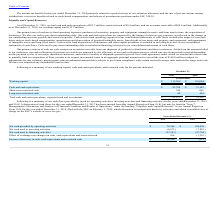According to Maxlinear's financial document, How much was the Net cash used in financing activities for the year ended December 31, 2018? Based on the financial document, the answer is $93.8 million. Also, can you calculate: What is the average Net cash provided by operating activities for the year ended December 31, 2019 to 2018? To answer this question, I need to perform calculations using the financial data. The calculation is: (78,348+102,689) / 2, which equals 90518.5 (in thousands). This is based on the information: "Net cash provided by operating activities $ 78,348 $ 102,689 cash provided by operating activities $ 78,348 $ 102,689..." The key data points involved are: 102,689, 78,348. Also, can you calculate: What is the average Net cash used in investing activities for the year ended December 31, 2019 to 2018? To answer this question, I need to perform calculations using the financial data. The calculation is: (6,973+7,825) / 2, which equals 7399 (in thousands). This is based on the information: "Net cash used in investing activities (6,973 ) (7,825 ) Net cash used in investing activities (6,973 ) (7,825 )..." The key data points involved are: 6,973, 7,825. Additionally, In which year was Net cash provided by operating activities less than 80,000 thousands? According to the financial document, 2019. The relevant text states: "2019 2018..." Also, What was the respective Net cash used in investing activities in 2019 and 2018? The document shows two values: (6,973) and (7,825) (in thousands). Also, When was the Form 10-K for the year ended December 31, 2018, filed with the SEC? According to the financial document, February 5, 2019. The relevant text states: "ar ended December 31, 2018, filed with the SEC on February 5, 2019, which discussion is incorporated herein by reference and which is available free of charge on the..." 